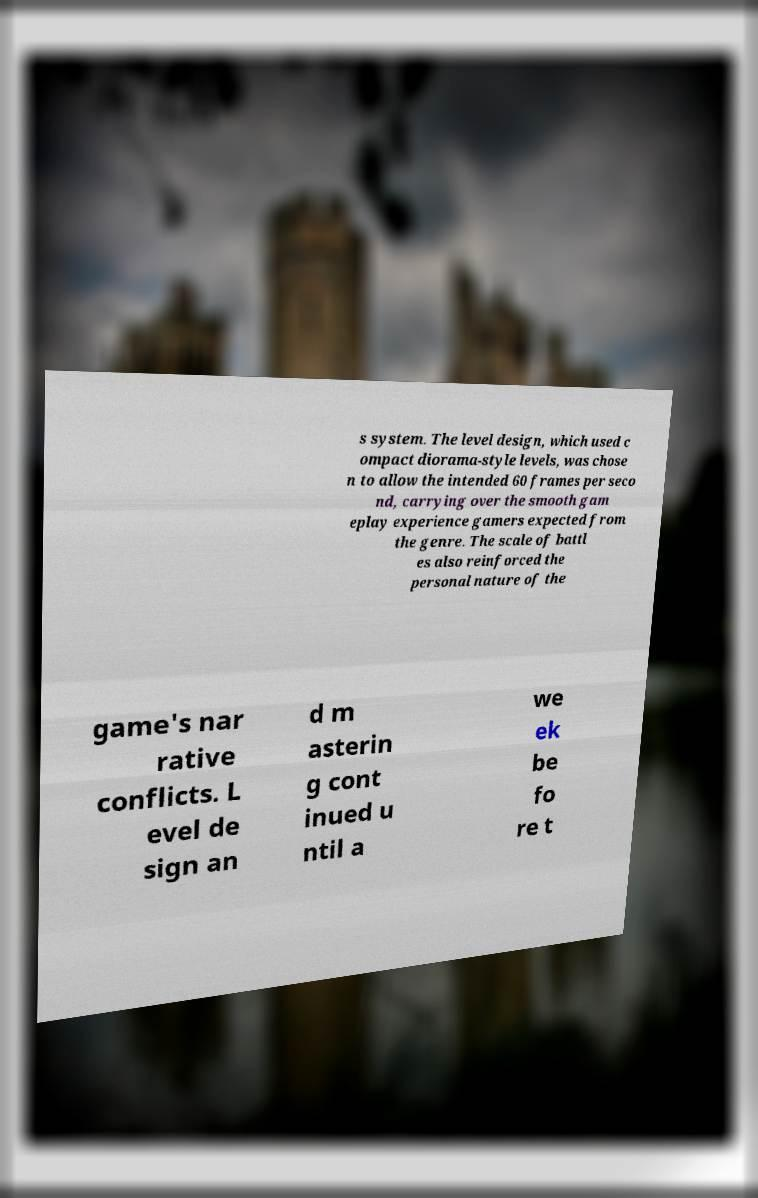Could you extract and type out the text from this image? s system. The level design, which used c ompact diorama-style levels, was chose n to allow the intended 60 frames per seco nd, carrying over the smooth gam eplay experience gamers expected from the genre. The scale of battl es also reinforced the personal nature of the game's nar rative conflicts. L evel de sign an d m asterin g cont inued u ntil a we ek be fo re t 